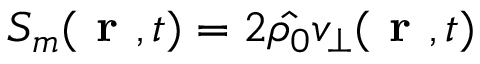Convert formula to latex. <formula><loc_0><loc_0><loc_500><loc_500>S _ { m } ( r , t ) = 2 \hat { \rho _ { 0 } } v _ { \bot } ( r , t )</formula> 